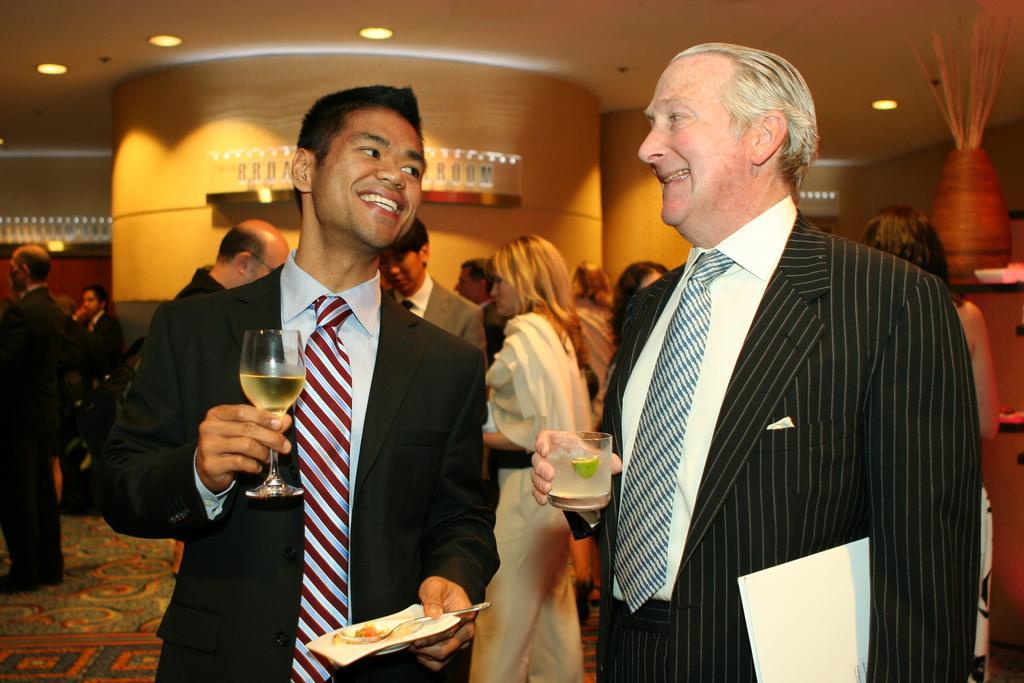How would you summarize this image in a sentence or two? In this image there are two people standing , a person holding a glass with a liquid in it , plate, spoon , a person holding a glass with a liquid in it and a book, and at the background there are group of people standing, carpet, lights, objects in the racks, sticks in a pot. 